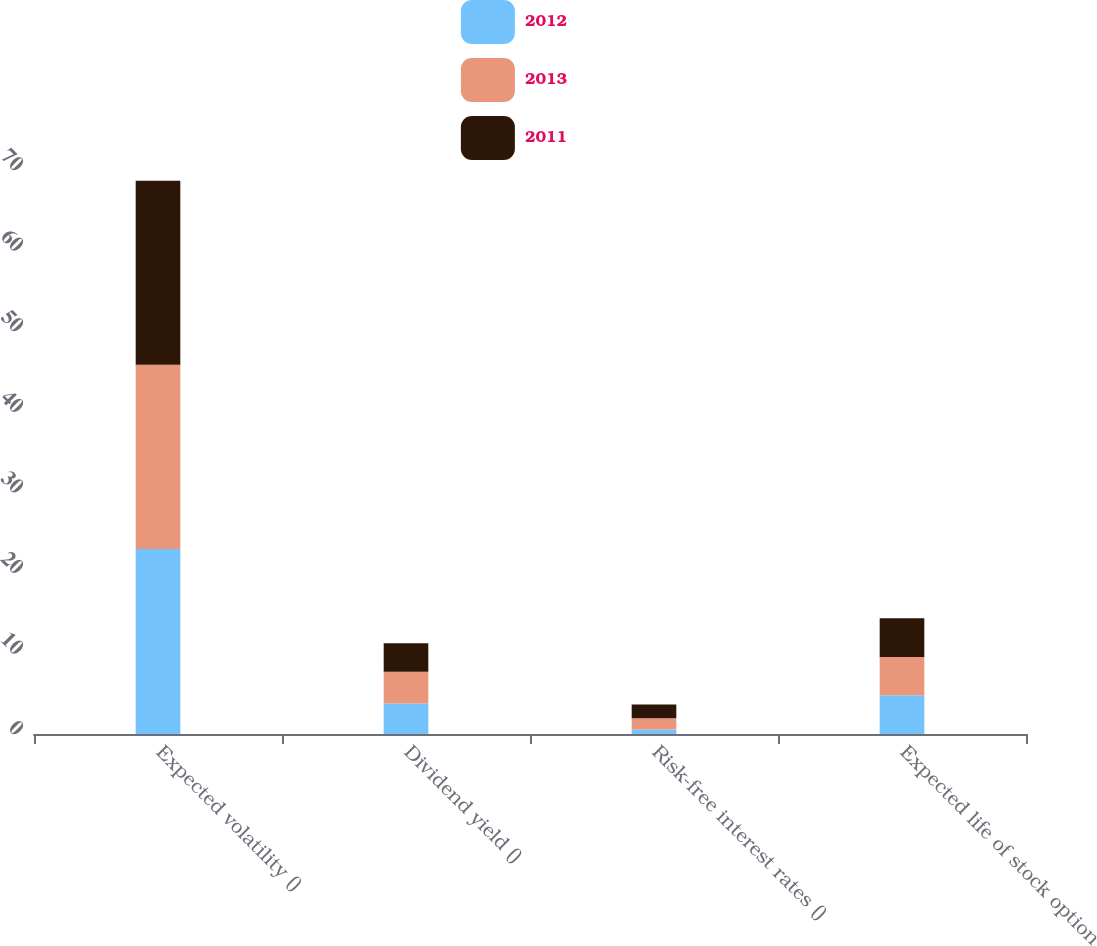Convert chart to OTSL. <chart><loc_0><loc_0><loc_500><loc_500><stacked_bar_chart><ecel><fcel>Expected volatility ()<fcel>Dividend yield ()<fcel>Risk-free interest rates ()<fcel>Expected life of stock option<nl><fcel>2012<fcel>22.95<fcel>3.77<fcel>0.57<fcel>4.8<nl><fcel>2013<fcel>22.89<fcel>3.97<fcel>1.38<fcel>4.75<nl><fcel>2011<fcel>22.83<fcel>3.51<fcel>1.72<fcel>4.82<nl></chart> 